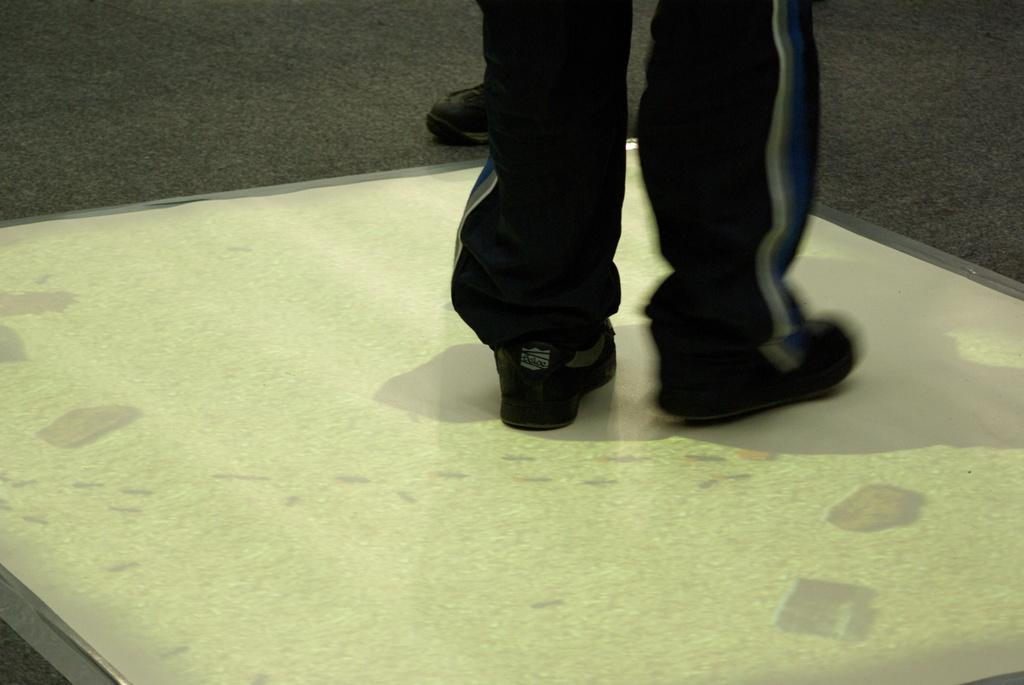What part of a person can be seen in the image? There are legs of a person visible in the image. Where are the legs located? The legs are on the floor. What can be seen in the background of the image? In the background, there appears to be a shoe. How much money is being exchanged between the person and the shoe in the image? There is no indication of money or any exchange taking place in the image. The image only shows legs on the floor and a shoe in the background. 